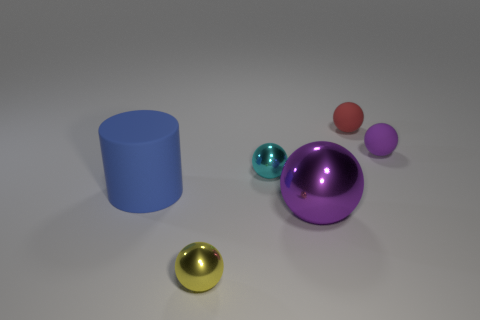What size is the rubber sphere in front of the small matte object left of the tiny matte sphere that is in front of the red matte thing?
Keep it short and to the point. Small. There is a tiny yellow metallic object; is its shape the same as the large thing in front of the blue rubber cylinder?
Provide a short and direct response. Yes. What number of other things are there of the same size as the purple metal thing?
Provide a short and direct response. 1. How big is the ball on the right side of the red matte thing?
Offer a very short reply. Small. How many cyan spheres have the same material as the cylinder?
Provide a short and direct response. 0. Does the purple object right of the small red ball have the same shape as the tiny red object?
Give a very brief answer. Yes. The large thing that is in front of the big blue matte cylinder has what shape?
Offer a terse response. Sphere. What size is the other rubber ball that is the same color as the large ball?
Give a very brief answer. Small. What is the material of the red object?
Offer a very short reply. Rubber. What is the color of the metal object that is the same size as the yellow metallic ball?
Provide a short and direct response. Cyan. 